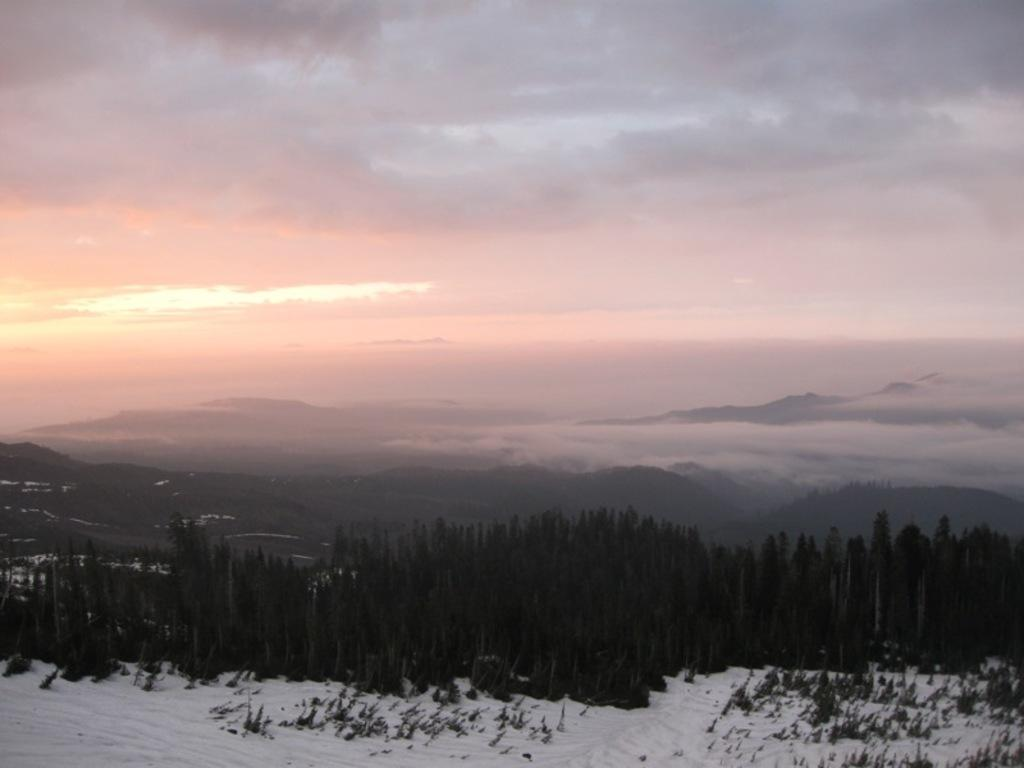What type of weather condition is depicted in the image? The image shows snow on the ground and trees, indicating a winter scene. What can be seen in the distance in the image? There are mountains in the background of the image. What atmospheric elements are present in the background of the image? Fog and clouds are visible in the background of the image. What shape is the silver head of the statue in the image? There is no statue or silver head present in the image. 